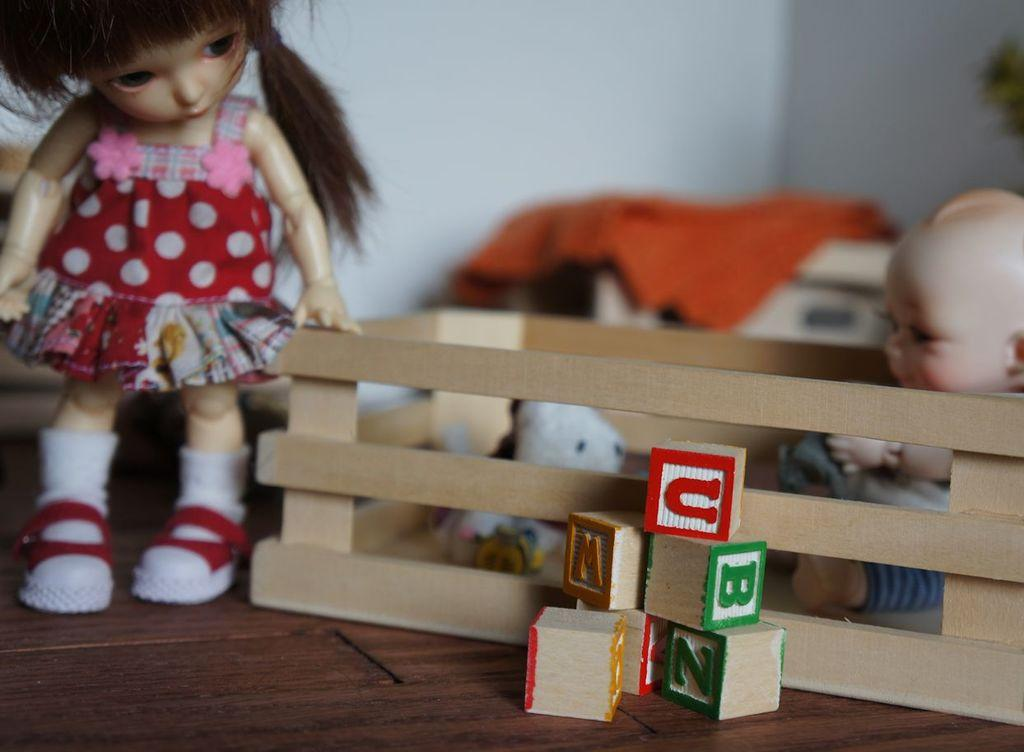What type of toy is present in the image? There is a doll and a baby doll in the image. What other objects are present on the table in the image? There are cubes on the table in the image. Can you describe the positioning of the doll, baby doll, and cubes in the image? The doll, baby doll, and cubes are placed on a table in the image. What type of garden can be seen in the image? There is no garden present in the image. How does the van contribute to the scene in the image? There is no van present in the image. 